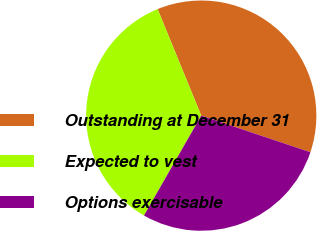Convert chart to OTSL. <chart><loc_0><loc_0><loc_500><loc_500><pie_chart><fcel>Outstanding at December 31<fcel>Expected to vest<fcel>Options exercisable<nl><fcel>36.34%<fcel>35.53%<fcel>28.14%<nl></chart> 